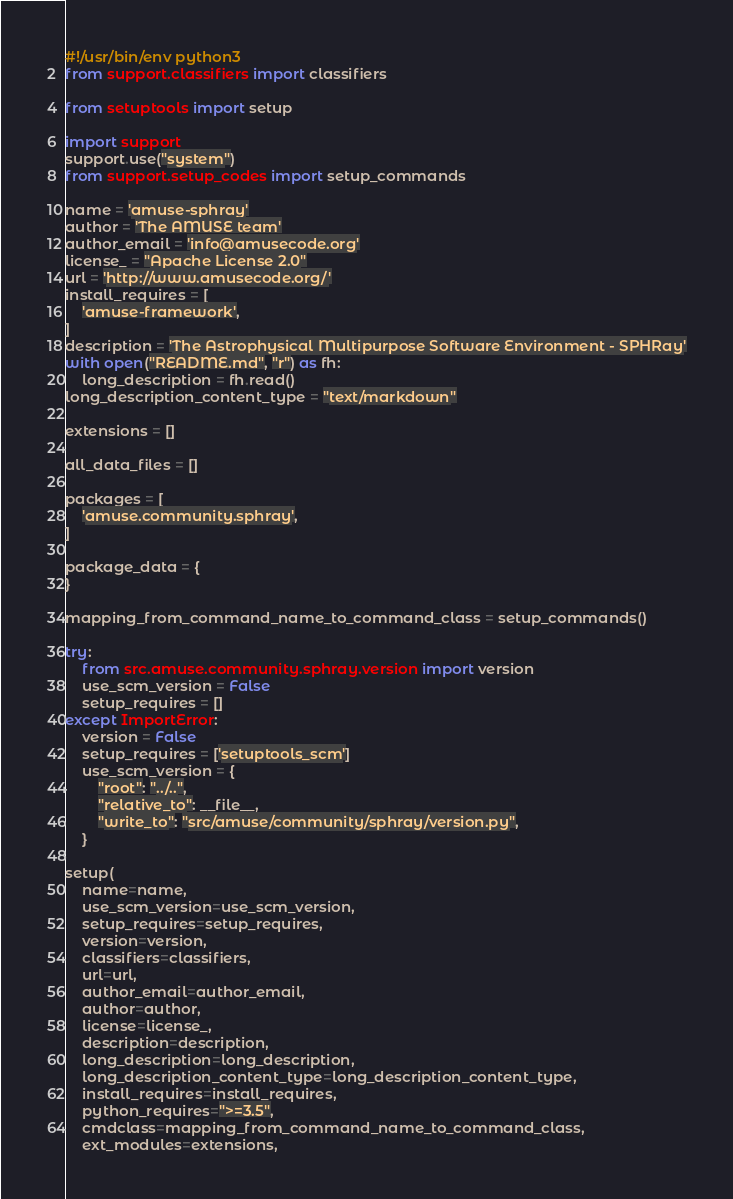<code> <loc_0><loc_0><loc_500><loc_500><_Python_>#!/usr/bin/env python3
from support.classifiers import classifiers

from setuptools import setup

import support
support.use("system")
from support.setup_codes import setup_commands

name = 'amuse-sphray'
author = 'The AMUSE team'
author_email = 'info@amusecode.org'
license_ = "Apache License 2.0"
url = 'http://www.amusecode.org/'
install_requires = [
    'amuse-framework',
]
description = 'The Astrophysical Multipurpose Software Environment - SPHRay'
with open("README.md", "r") as fh:
    long_description = fh.read()
long_description_content_type = "text/markdown"

extensions = []

all_data_files = []

packages = [
    'amuse.community.sphray',
]

package_data = {
}

mapping_from_command_name_to_command_class = setup_commands()

try:
    from src.amuse.community.sphray.version import version
    use_scm_version = False
    setup_requires = []
except ImportError:
    version = False
    setup_requires = ['setuptools_scm']
    use_scm_version = {
        "root": "../..",
        "relative_to": __file__,
        "write_to": "src/amuse/community/sphray/version.py",
    }

setup(
    name=name,
    use_scm_version=use_scm_version,
    setup_requires=setup_requires,
    version=version,
    classifiers=classifiers,
    url=url,
    author_email=author_email,
    author=author,
    license=license_,
    description=description,
    long_description=long_description,
    long_description_content_type=long_description_content_type,
    install_requires=install_requires,
    python_requires=">=3.5",
    cmdclass=mapping_from_command_name_to_command_class,
    ext_modules=extensions,</code> 